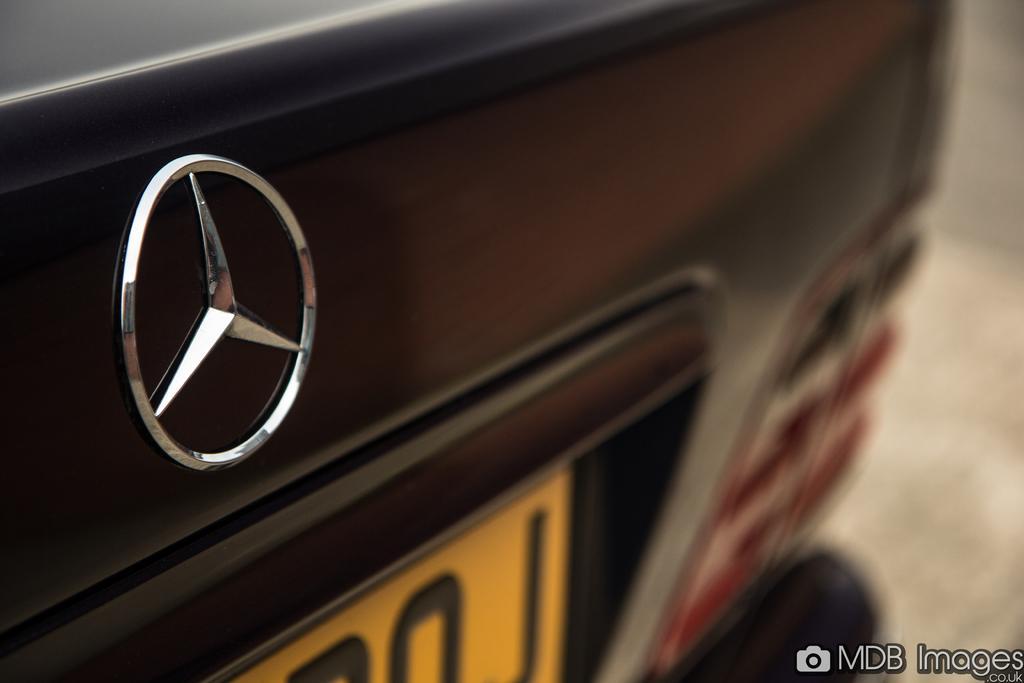Could you give a brief overview of what you see in this image? In this picture we can see a logo, number plate on a vehicle and in the background it is blurry and at the bottom right corner we can see some text. 